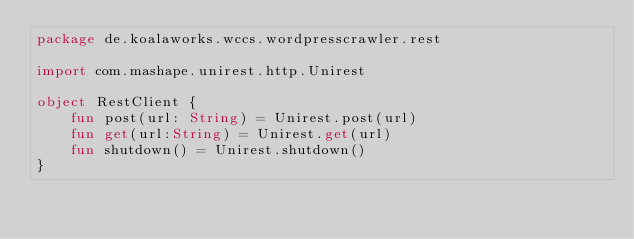Convert code to text. <code><loc_0><loc_0><loc_500><loc_500><_Kotlin_>package de.koalaworks.wccs.wordpresscrawler.rest

import com.mashape.unirest.http.Unirest

object RestClient {
    fun post(url: String) = Unirest.post(url)
    fun get(url:String) = Unirest.get(url)
    fun shutdown() = Unirest.shutdown()
}</code> 